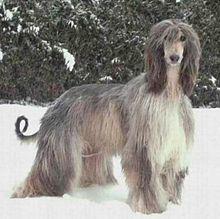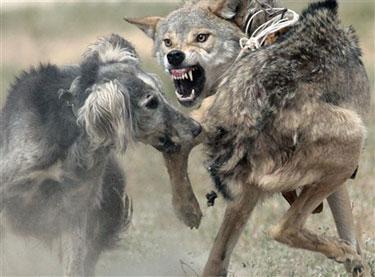The first image is the image on the left, the second image is the image on the right. Given the left and right images, does the statement "the dog on the right image is facing left." hold true? Answer yes or no. No. 